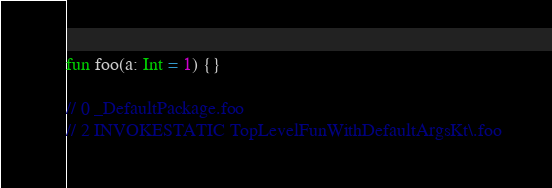Convert code to text. <code><loc_0><loc_0><loc_500><loc_500><_Kotlin_>fun foo(a: Int = 1) {}

// 0 _DefaultPackage.foo
// 2 INVOKESTATIC TopLevelFunWithDefaultArgsKt\.foo
</code> 